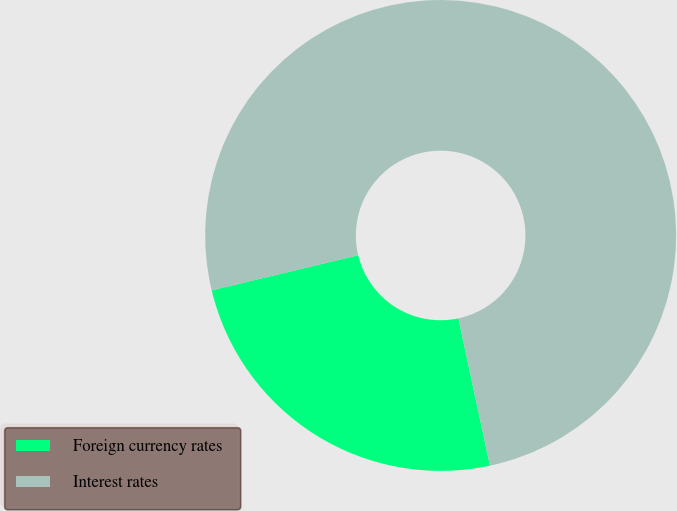Convert chart. <chart><loc_0><loc_0><loc_500><loc_500><pie_chart><fcel>Foreign currency rates<fcel>Interest rates<nl><fcel>24.62%<fcel>75.38%<nl></chart> 